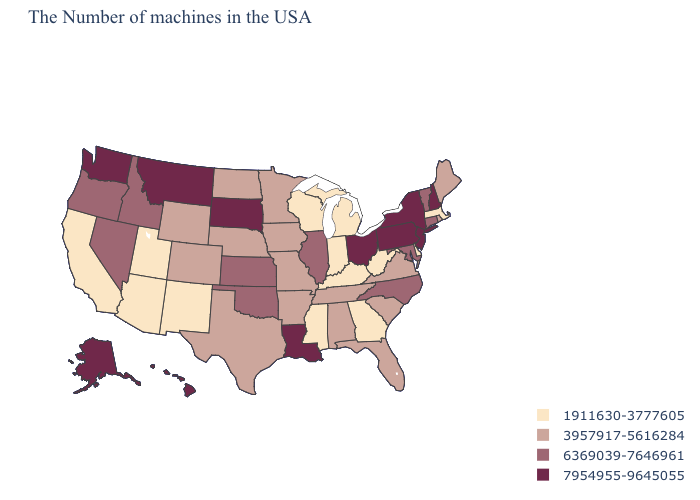What is the value of Tennessee?
Keep it brief. 3957917-5616284. Does Hawaii have the highest value in the USA?
Concise answer only. Yes. Does Alaska have the highest value in the West?
Quick response, please. Yes. What is the lowest value in the West?
Give a very brief answer. 1911630-3777605. Name the states that have a value in the range 1911630-3777605?
Keep it brief. Massachusetts, Delaware, West Virginia, Georgia, Michigan, Kentucky, Indiana, Wisconsin, Mississippi, New Mexico, Utah, Arizona, California. What is the value of Utah?
Concise answer only. 1911630-3777605. Among the states that border Wyoming , which have the lowest value?
Quick response, please. Utah. Does Iowa have a lower value than Montana?
Answer briefly. Yes. Name the states that have a value in the range 1911630-3777605?
Short answer required. Massachusetts, Delaware, West Virginia, Georgia, Michigan, Kentucky, Indiana, Wisconsin, Mississippi, New Mexico, Utah, Arizona, California. What is the highest value in the Northeast ?
Answer briefly. 7954955-9645055. What is the highest value in the USA?
Be succinct. 7954955-9645055. Among the states that border New Hampshire , does Maine have the highest value?
Answer briefly. No. Name the states that have a value in the range 3957917-5616284?
Write a very short answer. Maine, Rhode Island, Virginia, South Carolina, Florida, Alabama, Tennessee, Missouri, Arkansas, Minnesota, Iowa, Nebraska, Texas, North Dakota, Wyoming, Colorado. What is the highest value in the South ?
Quick response, please. 7954955-9645055. What is the value of Alabama?
Be succinct. 3957917-5616284. 